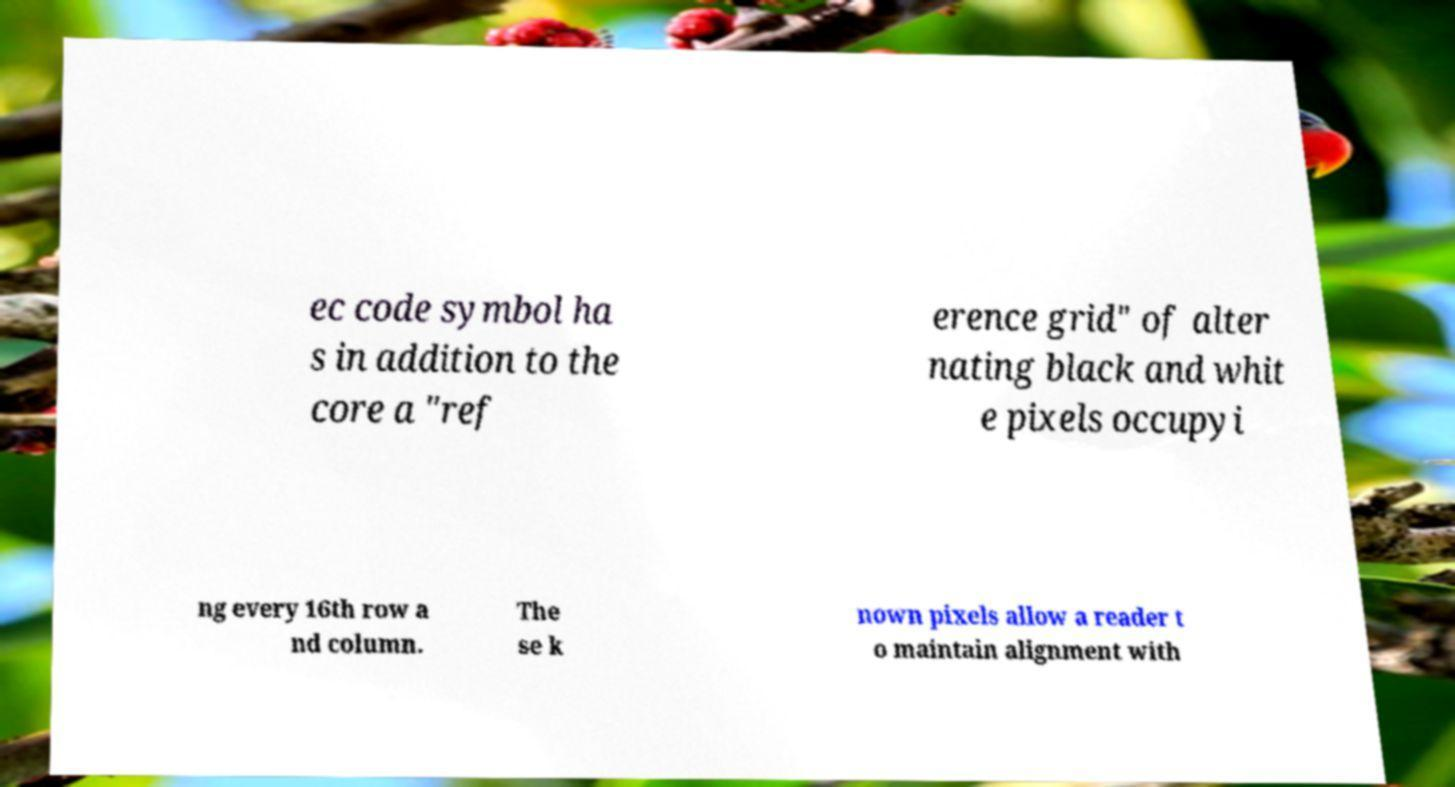I need the written content from this picture converted into text. Can you do that? ec code symbol ha s in addition to the core a "ref erence grid" of alter nating black and whit e pixels occupyi ng every 16th row a nd column. The se k nown pixels allow a reader t o maintain alignment with 